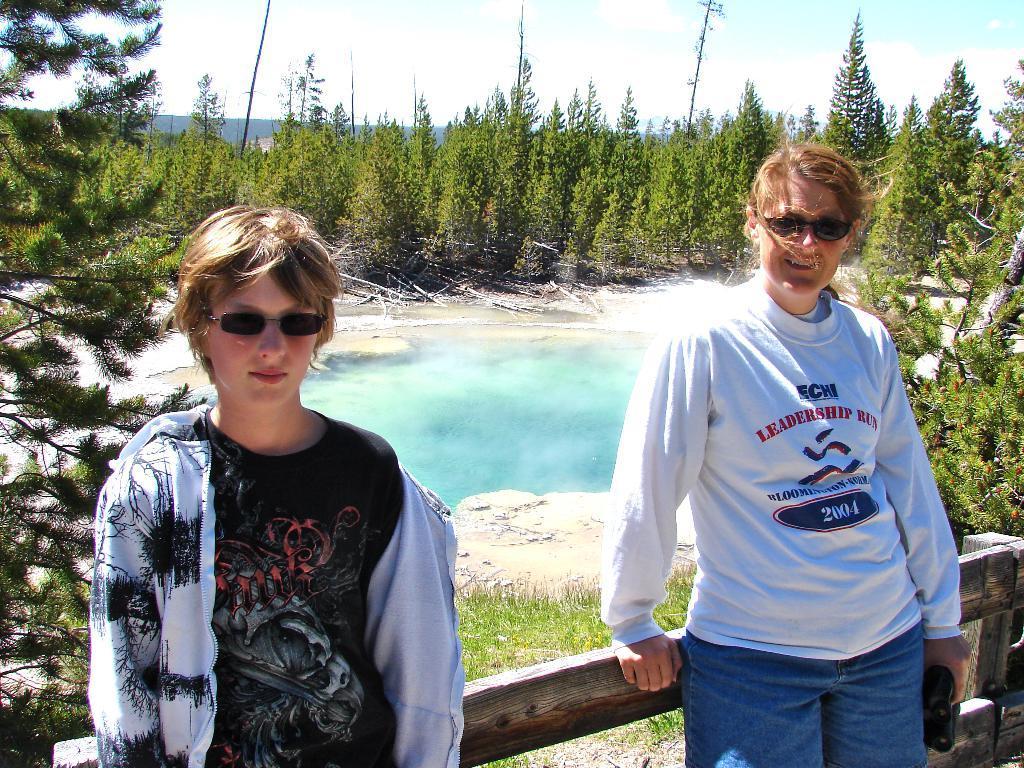Could you give a brief overview of what you see in this image? In this image there is one man and one woman standing and there are some wooden sticks, and in the background there is a pond, trees, grass, and some rocks and some poles and buildings. At the top there is sky. 